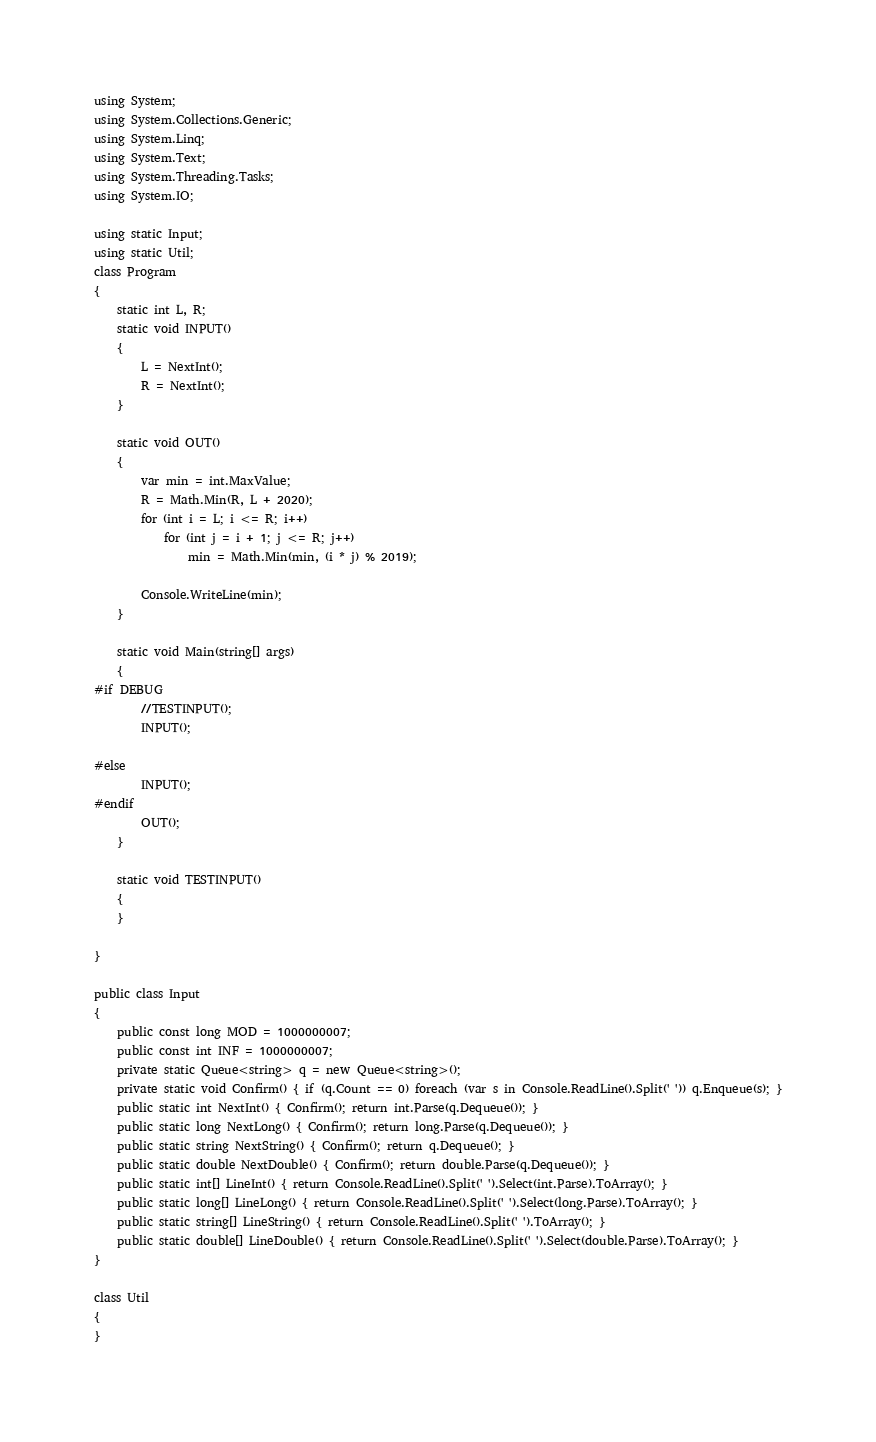<code> <loc_0><loc_0><loc_500><loc_500><_C#_>using System;
using System.Collections.Generic;
using System.Linq;
using System.Text;
using System.Threading.Tasks;
using System.IO;

using static Input;
using static Util;
class Program
{
    static int L, R;
    static void INPUT()
    {
        L = NextInt();
        R = NextInt();
    }

    static void OUT()
    {
        var min = int.MaxValue;
        R = Math.Min(R, L + 2020);
        for (int i = L; i <= R; i++)
            for (int j = i + 1; j <= R; j++)
                min = Math.Min(min, (i * j) % 2019);

        Console.WriteLine(min);
    }

    static void Main(string[] args)
    {
#if DEBUG  
        //TESTINPUT();
        INPUT();

#else
        INPUT();
#endif
        OUT();
    }

    static void TESTINPUT()
    {
    }

}

public class Input
{
    public const long MOD = 1000000007;
    public const int INF = 1000000007;
    private static Queue<string> q = new Queue<string>();
    private static void Confirm() { if (q.Count == 0) foreach (var s in Console.ReadLine().Split(' ')) q.Enqueue(s); }
    public static int NextInt() { Confirm(); return int.Parse(q.Dequeue()); }
    public static long NextLong() { Confirm(); return long.Parse(q.Dequeue()); }
    public static string NextString() { Confirm(); return q.Dequeue(); }
    public static double NextDouble() { Confirm(); return double.Parse(q.Dequeue()); }
    public static int[] LineInt() { return Console.ReadLine().Split(' ').Select(int.Parse).ToArray(); }
    public static long[] LineLong() { return Console.ReadLine().Split(' ').Select(long.Parse).ToArray(); }
    public static string[] LineString() { return Console.ReadLine().Split(' ').ToArray(); }
    public static double[] LineDouble() { return Console.ReadLine().Split(' ').Select(double.Parse).ToArray(); }
}

class Util
{
}
</code> 